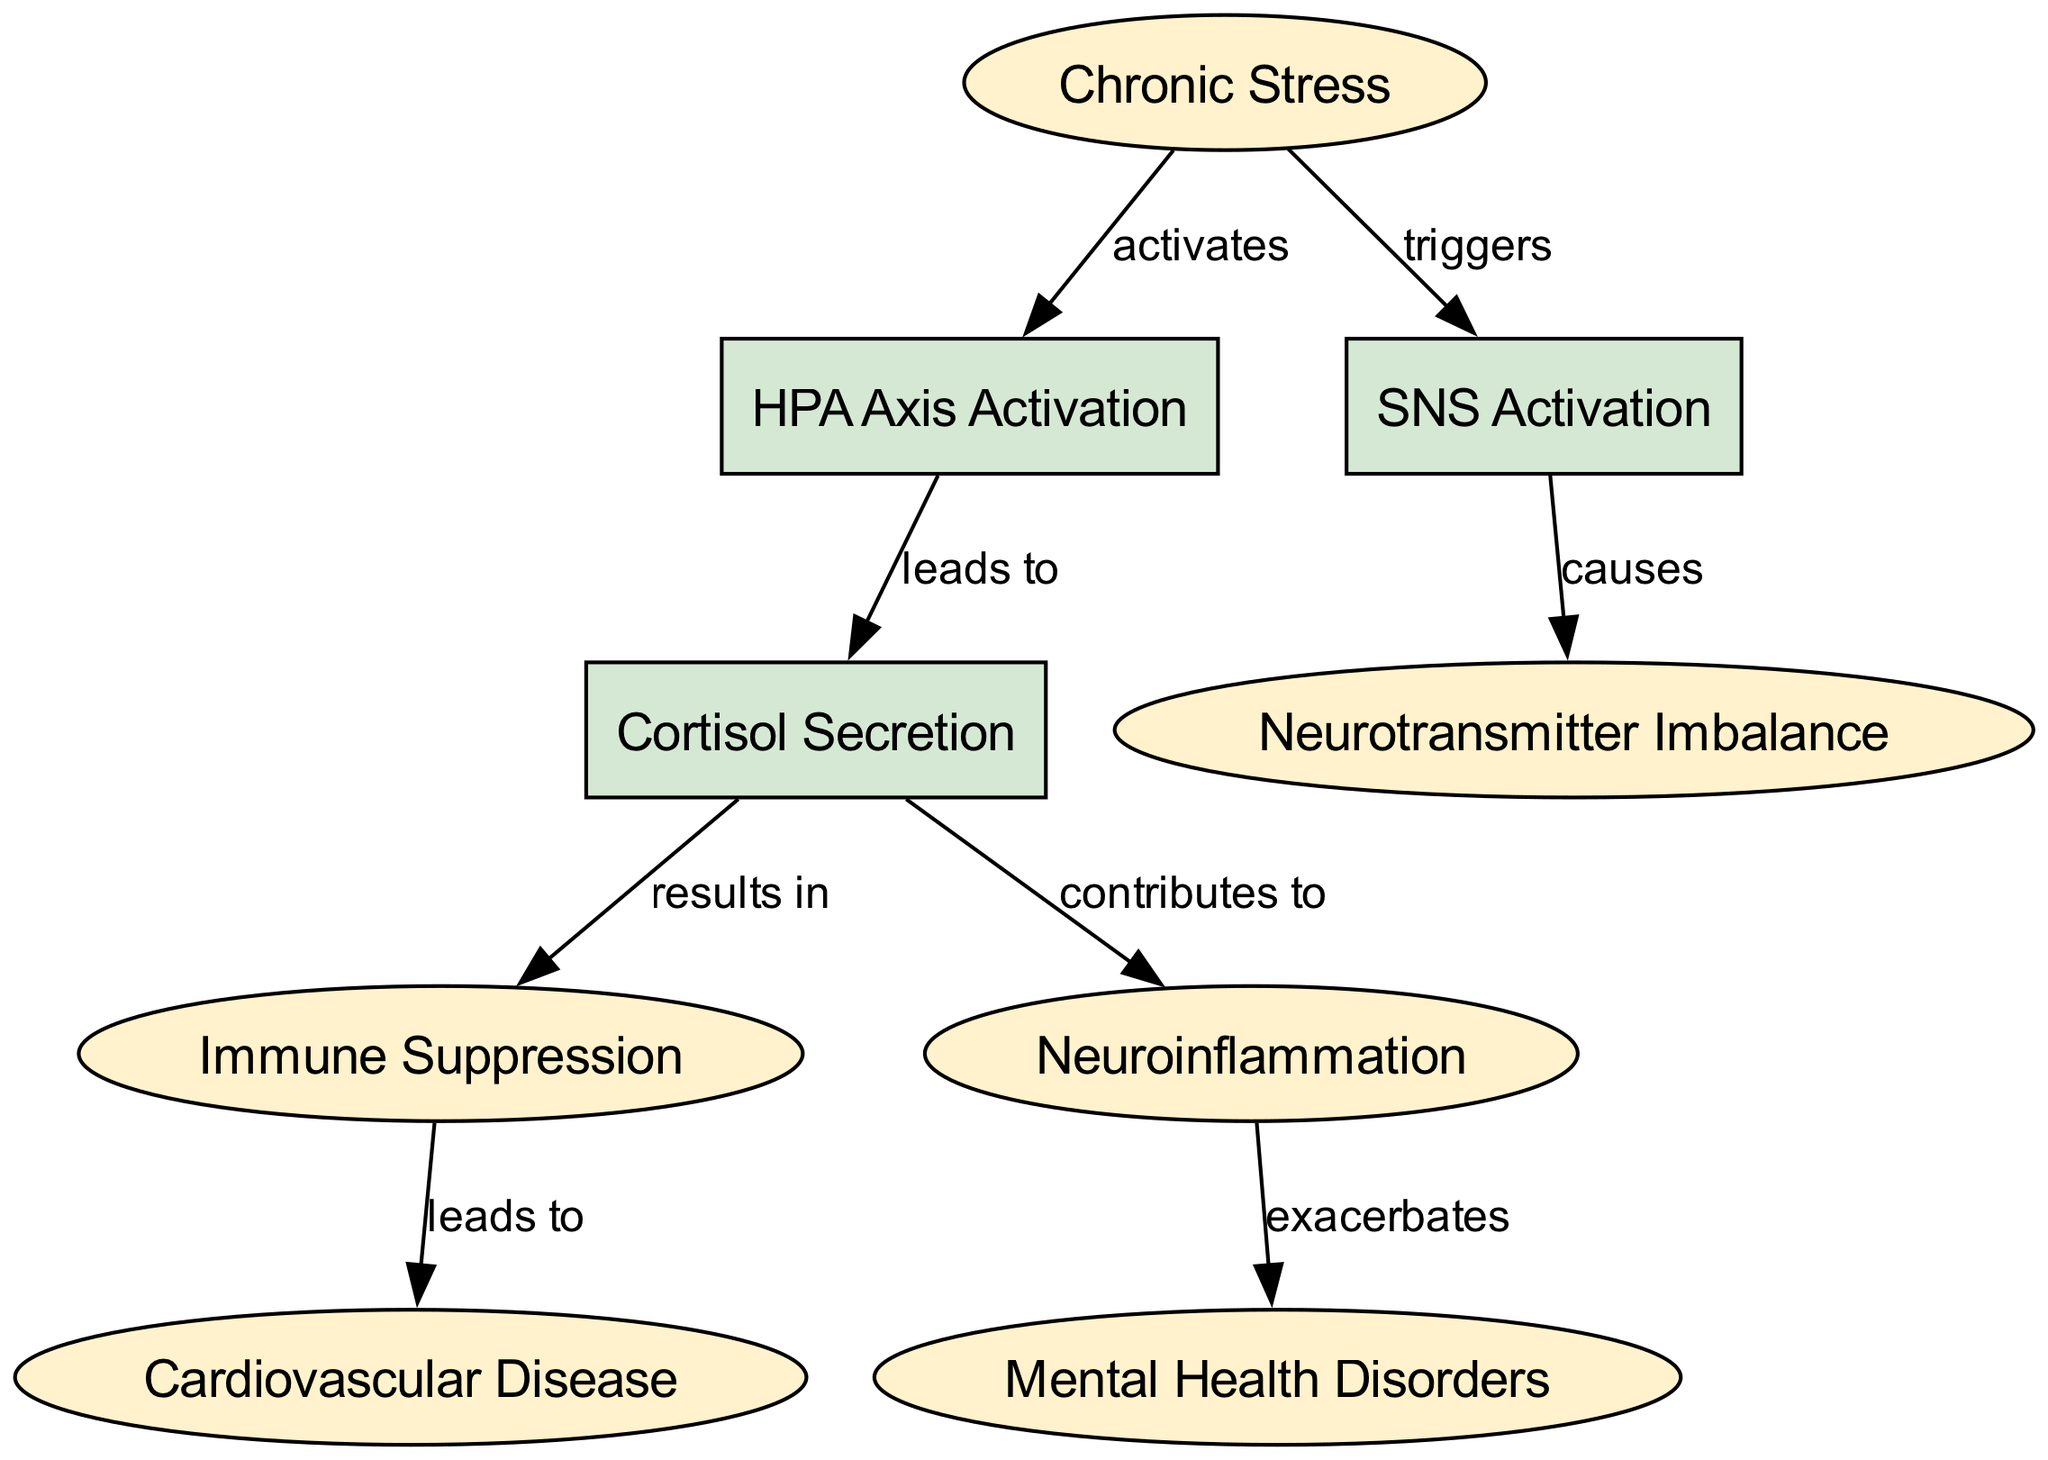What is the main condition depicted in the diagram? The diagram's main condition is represented by the first node, which is labeled "Chronic Stress." This node encapsulates the primary focus of the diagram and is the starting point for the relationships depicted.
Answer: Chronic Stress How many nodes are present in the diagram? To find the total number of nodes, we count each unique node listed in the data section. There are ten distinct nodes shown, each representing either a condition or a process.
Answer: 10 What process is activated by chronic stress? By examining the edges connected to the node "Chronic Stress," it can be seen that it activates the "HPA Axis." This connection indicates a direct influence from chronic stress to this particular process.
Answer: HPA Axis Activation What are the consequences of cortisol secretion as shown in the diagram? The edges that extend from the "Cortisol Secretion" node indicate its outcomes, specifically pointing to "Immune Suppression" and "Neuroinflammation." This means these two conditions result from the process of cortisol secretion triggered by chronic stress.
Answer: Immune Suppression, Neuroinflammation How does SNS activation affect neurotransmitter balance? From the diagram's flow, it is clear that "SNS Activation" causes "Neurotransmitter Imbalance." This implies a direct connection where the activation of the sympathetic nervous system disrupts normal neurotransmitter levels.
Answer: Neurotransmitter Imbalance What is the relation between immune suppression and cardiovascular disease? Following the directed edges, the relationship is that "Immune Suppression" leads to "Cardiovascular Disease." This signifies that the suppression of the immune system as an outcome of chronic stress can result in an increased risk of cardiovascular issues.
Answer: Cardiovascular Disease Which condition exacerbates mental health disorders according to the diagram? The direction in the diagram shows that "Neuroinflammation" exacerbates "Mental Health Disorders." This suggests that neuroinflammation as a consequence of chronic stress contributes to worsening mental health conditions.
Answer: Neuroinflammation What is the connection between neurotransmitter imbalance and SNS activation? The diagram illustrates a causal relationship where "SNS Activation" leads to "Neurotransmitter Imbalance." This shows that the activation of the sympathetic nervous system has a direct effect on neurotransmitter levels in the body.
Answer: Causes What are the disorders linked to the effects of chronic stress according to the diagram? Based on the various edges leading out from the nodes, the disorders connected to chronic stress are "Mental Health Disorders" and "Cardiovascular Disease." Both conditions highlight the health implications associated with chronic stress as depicted in the diagram.
Answer: Mental Health Disorders, Cardiovascular Disease 